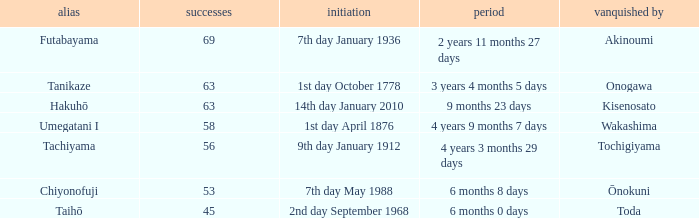How many wins were held before being defeated by toda? 1.0. 